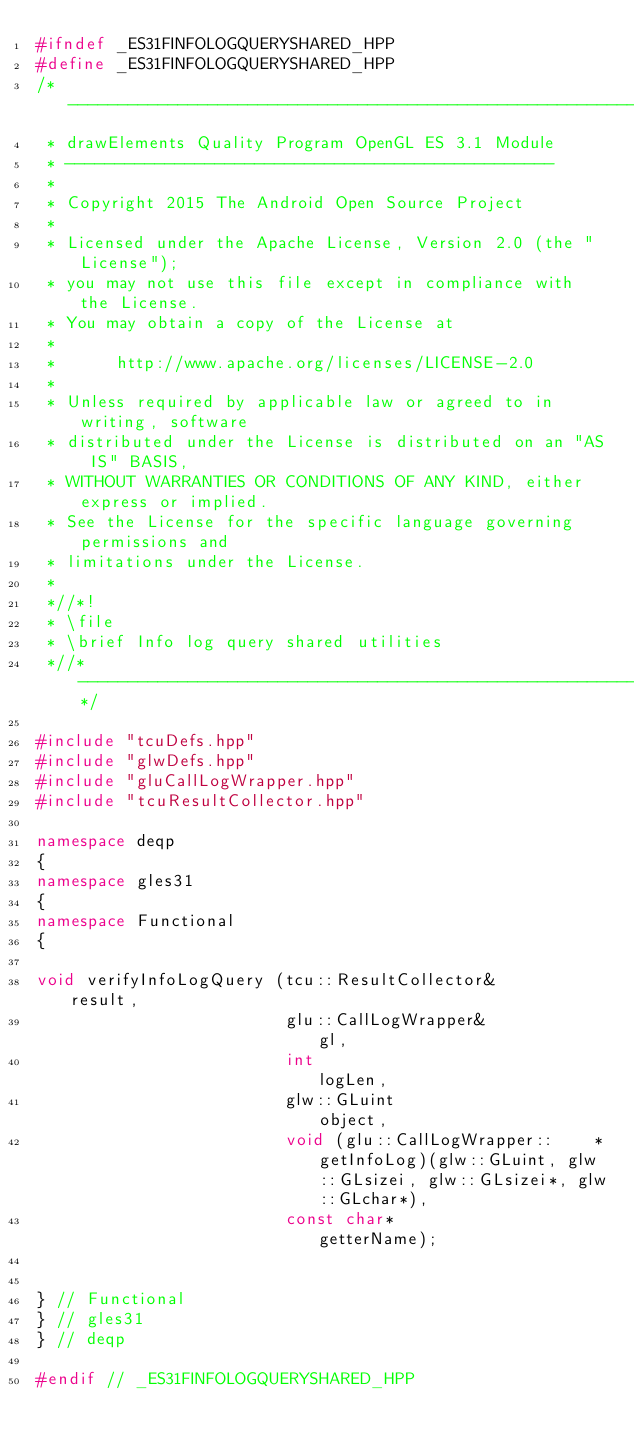<code> <loc_0><loc_0><loc_500><loc_500><_C++_>#ifndef _ES31FINFOLOGQUERYSHARED_HPP
#define _ES31FINFOLOGQUERYSHARED_HPP
/*-------------------------------------------------------------------------
 * drawElements Quality Program OpenGL ES 3.1 Module
 * -------------------------------------------------
 *
 * Copyright 2015 The Android Open Source Project
 *
 * Licensed under the Apache License, Version 2.0 (the "License");
 * you may not use this file except in compliance with the License.
 * You may obtain a copy of the License at
 *
 *      http://www.apache.org/licenses/LICENSE-2.0
 *
 * Unless required by applicable law or agreed to in writing, software
 * distributed under the License is distributed on an "AS IS" BASIS,
 * WITHOUT WARRANTIES OR CONDITIONS OF ANY KIND, either express or implied.
 * See the License for the specific language governing permissions and
 * limitations under the License.
 *
 *//*!
 * \file
 * \brief Info log query shared utilities
 *//*--------------------------------------------------------------------*/

#include "tcuDefs.hpp"
#include "glwDefs.hpp"
#include "gluCallLogWrapper.hpp"
#include "tcuResultCollector.hpp"

namespace deqp
{
namespace gles31
{
namespace Functional
{

void verifyInfoLogQuery (tcu::ResultCollector&			result,
						 glu::CallLogWrapper&			gl,
						 int							logLen,
						 glw::GLuint					object,
						 void (glu::CallLogWrapper::	*getInfoLog)(glw::GLuint, glw::GLsizei, glw::GLsizei*, glw::GLchar*),
						 const char*					getterName);


} // Functional
} // gles31
} // deqp

#endif // _ES31FINFOLOGQUERYSHARED_HPP
</code> 